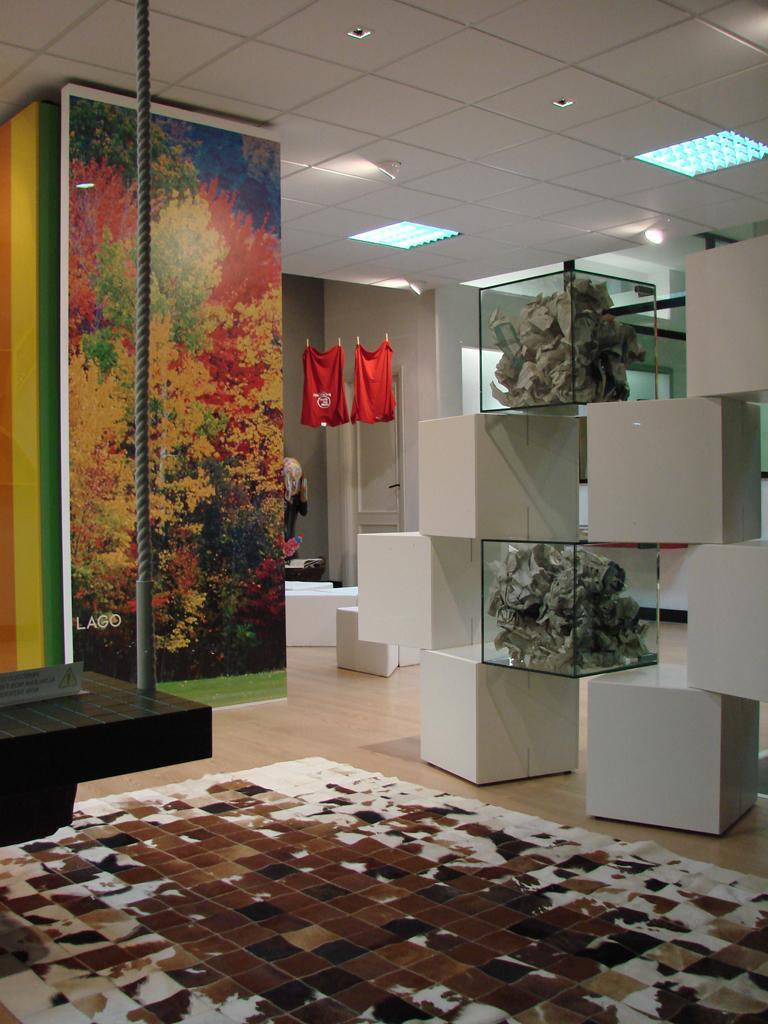Describe this image in one or two sentences. This picture is clicked inside the room. At the bottom of the picture, we see a carpet in white and brown color. On the left side, we see a black table and a banner or a graffiti. On the right side, we see white blocks and glass boxes. Beside that, we see two red T-shirts are hanged to the hangers. Beside that, we see a white wall. At the top of the picture, we see the ceiling of the room. 